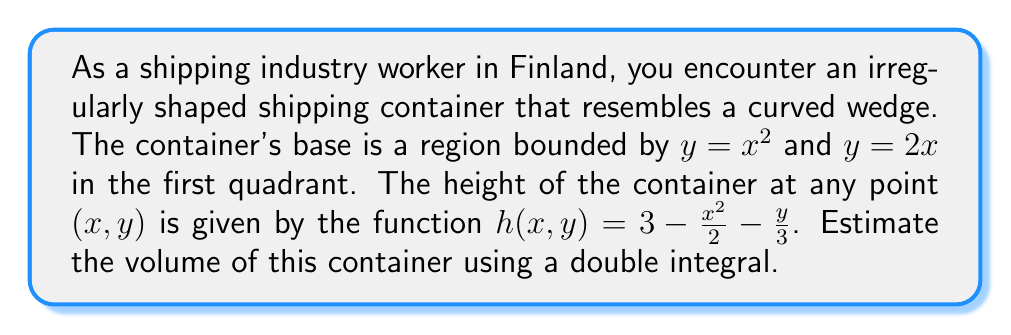Can you solve this math problem? To solve this problem, we need to set up and evaluate a double integral. Let's break it down step by step:

1) First, we need to determine the limits of integration. The base of the container is bounded by $y = x^2$ and $y = 2x$ in the first quadrant. These curves intersect when:

   $x^2 = 2x$
   $x^2 - 2x = 0$
   $x(x - 2) = 0$
   $x = 0$ or $x = 2$

   Since we're in the first quadrant, we'll use $x = 2$ as the upper limit for $x$.

2) The volume can be calculated using the double integral:

   $$V = \int_{0}^{2} \int_{x^2}^{2x} h(x,y) \, dy \, dx$$

3) Substituting the function for $h(x,y)$:

   $$V = \int_{0}^{2} \int_{x^2}^{2x} (3 - \frac{x^2}{2} - \frac{y}{3}) \, dy \, dx$$

4) Let's evaluate the inner integral first:

   $$\int_{x^2}^{2x} (3 - \frac{x^2}{2} - \frac{y}{3}) \, dy = [3y - \frac{x^2}{2}y - \frac{y^2}{6}]_{x^2}^{2x}$$

5) Evaluating at the limits:

   $$(6x - x^2x - \frac{4x^2}{6}) - (3x^2 - \frac{x^2x^2}{2} - \frac{x^4}{6})$$

6) Simplifying:

   $$6x - x^3 - \frac{2x^2}{3} - 3x^2 + \frac{x^4}{2} + \frac{x^4}{6}$$

   $$= 6x - x^3 - \frac{11x^2}{3} + \frac{2x^4}{3}$$

7) Now we can evaluate the outer integral:

   $$V = \int_{0}^{2} (6x - x^3 - \frac{11x^2}{3} + \frac{2x^4}{3}) \, dx$$

8) Integrating:

   $$V = [3x^2 - \frac{x^4}{4} - \frac{11x^3}{9} + \frac{2x^5}{15}]_{0}^{2}$$

9) Evaluating at the limits:

   $$V = (12 - 4 - \frac{88}{9} + \frac{64}{15}) - (0 - 0 - 0 + 0)$$

10) Simplifying:

    $$V = 12 - 4 - \frac{88}{9} + \frac{64}{15} = \frac{180}{15} - \frac{60}{15} - \frac{220}{45} + \frac{64}{15} = \frac{184}{15} - \frac{220}{45} = \frac{552}{45} - \frac{220}{45} = \frac{332}{45}$$

Therefore, the volume of the container is $\frac{332}{45}$ cubic units.
Answer: $\frac{332}{45}$ cubic units 